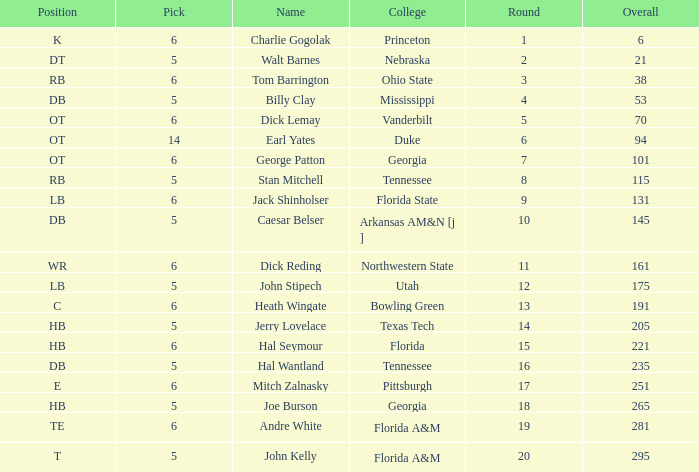What is Name, when Overall is less than 175, and when College is "Georgia"? George Patton. 